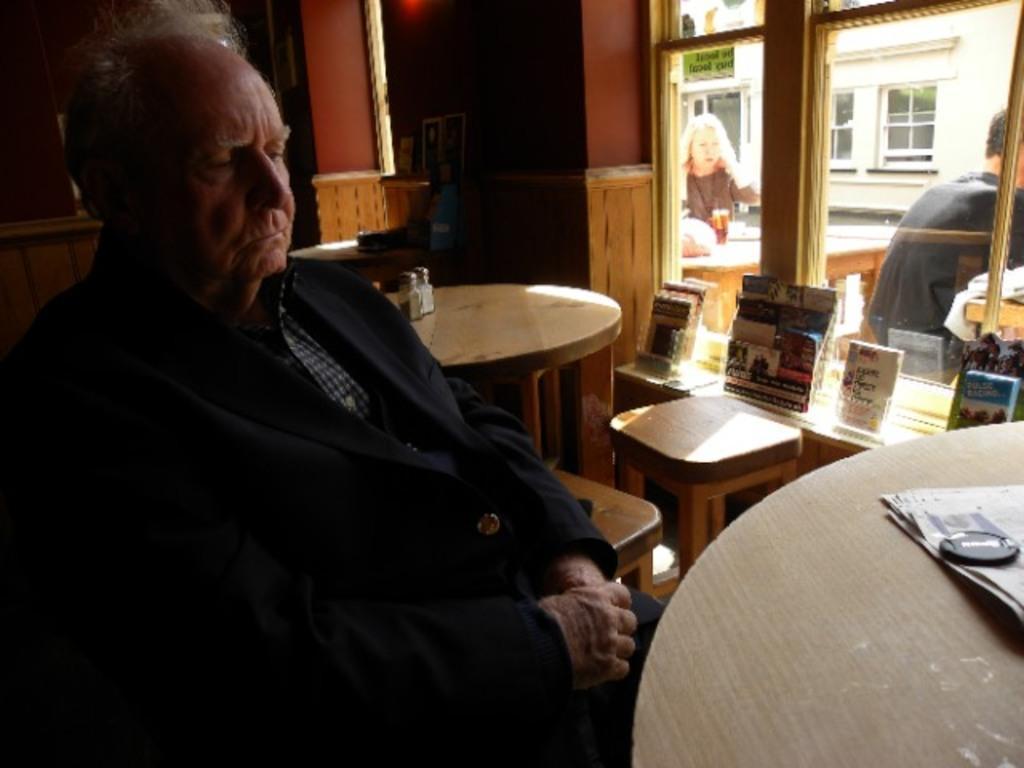Can you describe this image briefly? In this picture there is a old man wearing a suit sitting in the chair in front of a table on which a paper was there. Behind him there is another table and some books were placed on the desk. Through the windows there are some people sitting outside. In the background there are some buildings here. 